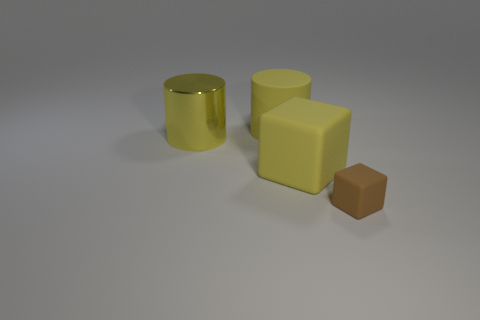Is there any other thing that has the same size as the brown cube?
Make the answer very short. No. Is there a rubber sphere that has the same color as the big rubber cube?
Your response must be concise. No. How many other things are the same shape as the shiny thing?
Provide a short and direct response. 1. There is a thing that is behind the yellow metal cylinder; what shape is it?
Keep it short and to the point. Cylinder. Does the metal object have the same shape as the matte object in front of the large yellow cube?
Offer a very short reply. No. There is a rubber thing that is behind the brown matte thing and right of the rubber cylinder; how big is it?
Your answer should be very brief. Large. There is a object that is both to the left of the large yellow matte block and on the right side of the metallic cylinder; what is its color?
Make the answer very short. Yellow. Are there any other things that have the same material as the big yellow cube?
Your response must be concise. Yes. Are there fewer small rubber objects in front of the brown cube than big yellow things that are in front of the yellow matte cylinder?
Keep it short and to the point. Yes. Are there any other things that are the same color as the tiny object?
Your answer should be very brief. No. 